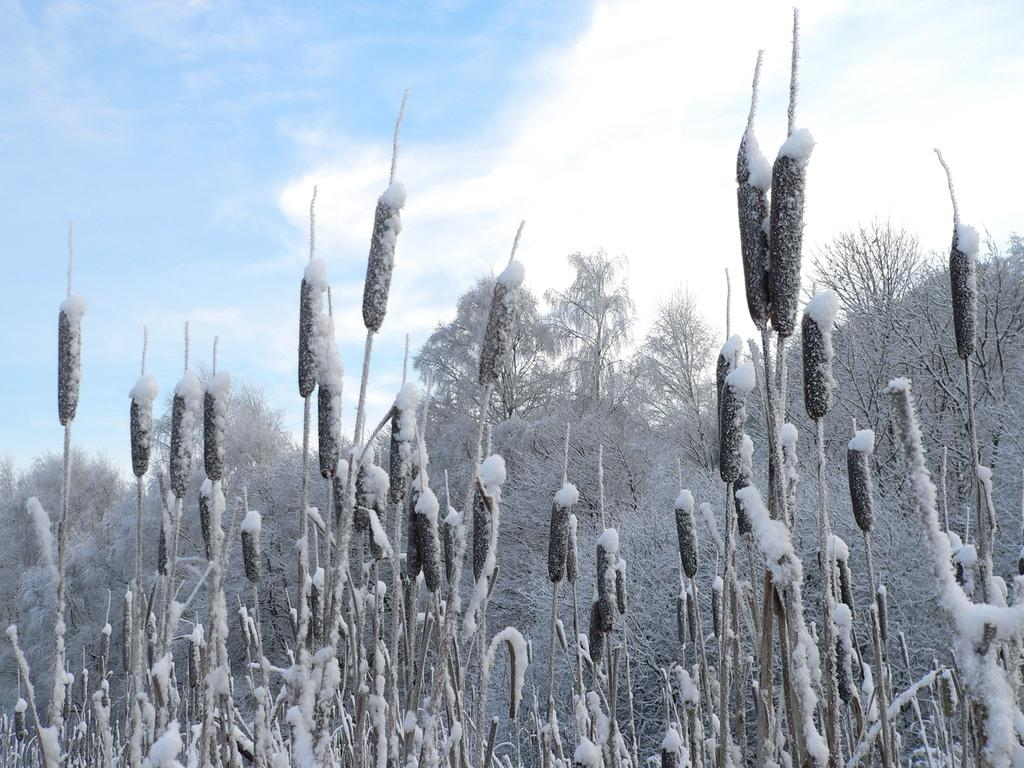What type of vegetation can be seen in the image? There are trees in the image. What is covering the trees in the image? The trees are covered with snow. What type of insect can be seen flying around the trees in the image? There are no insects visible in the image; the trees are covered with snow. 